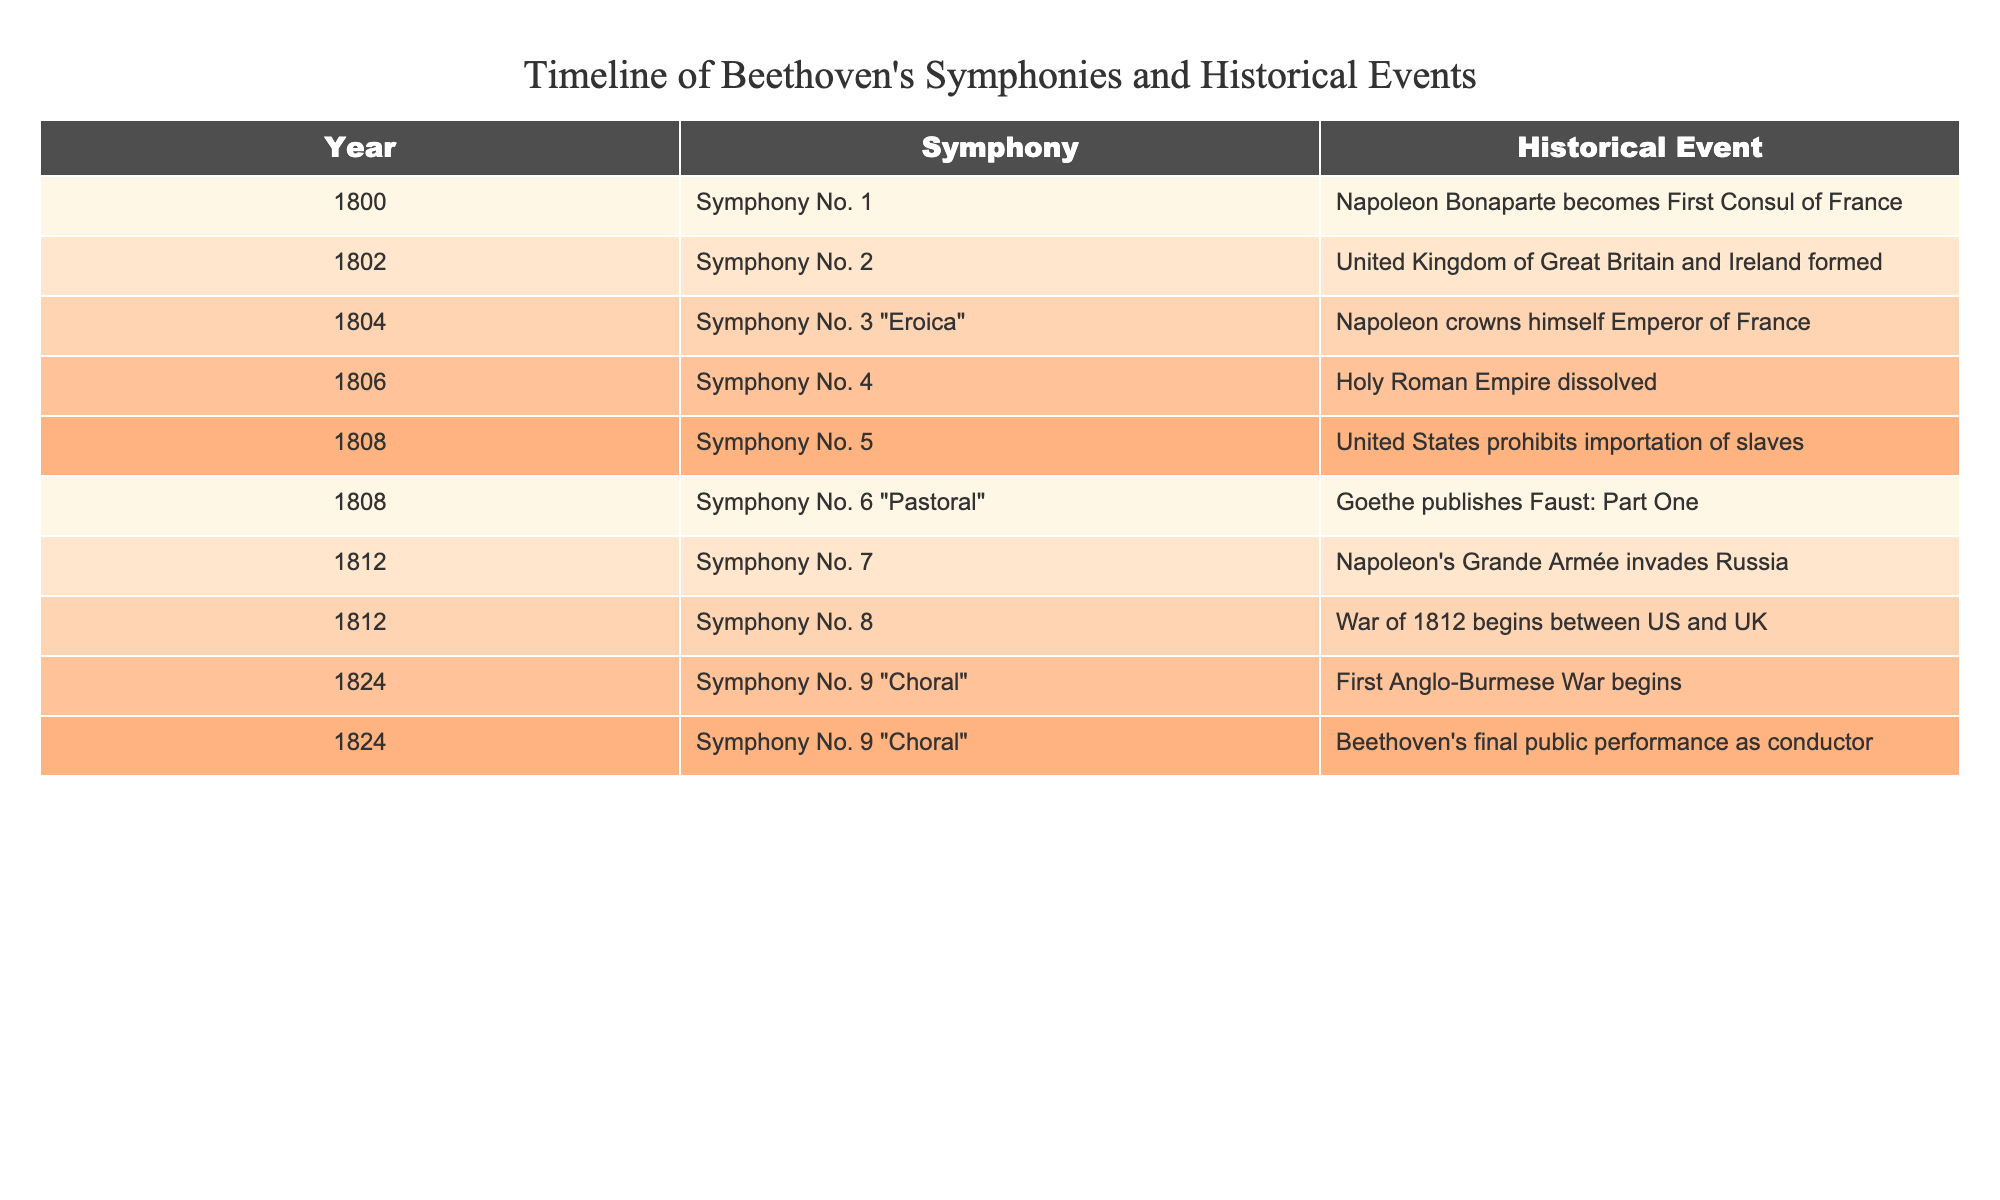What year was Beethoven's Symphony No. 5 composed? By looking at the table, Symphony No. 5 is listed under the year 1808.
Answer: 1808 What historical event is associated with Symphony No. 3 "Eroica"? The table shows that Symphony No. 3 "Eroica" is associated with Napoleon crowning himself Emperor of France in 1804.
Answer: Napoleon crowns himself Emperor of France Which symphony was composed the same year the Holy Roman Empire was dissolved? The table indicates that Symphony No. 4 was composed in 1806, which is the same year the Holy Roman Empire was dissolved.
Answer: Symphony No. 4 How many symphonies did Beethoven compose before 1810? Reviewing the table, Beethoven composed Symphony No. 1, No. 2, No. 3, No. 4, No. 5, and No. 6 before 1810, totaling 6 symphonies.
Answer: 6 Was Symphony No. 9 "Choral" performed before or after the start of the First Anglo-Burmese War? According to the table, Symphony No. 9 "Choral" was composed in 1824, and the First Anglo-Burmese War began in the same year, indicating the symphony was performed at the same time.
Answer: Same year What is the difference in years between the compositions of Symphony No. 7 and Symphony No. 2? Looking at the table, Symphony No. 7 was composed in 1812 and Symphony No. 2 was composed in 1802. Thus, the difference is 1812 - 1802 = 10 years.
Answer: 10 years Which symphony corresponds to the historical event of the War of 1812? The table indicates that Symphony No. 8 is associated with the War of 1812, which began between the US and UK in 1812.
Answer: Symphony No. 8 Is it true that Beethoven's final public performance as conductor was linked with the same symphony? Yes, the table shows that Beethoven's final public performance as conductor occurred in 1824, along with the composition of Symphony No. 9 "Choral".
Answer: Yes How many symphonies featured in the table were composed in 1808? The table lists two symphonies composed in 1808: Symphony No. 5 and Symphony No. 6 "Pastoral". Therefore, there are 2 symphonies.
Answer: 2 What significant American historical event coincides with the composition of Symphony No. 5? The table indicates that the United States prohibited the importation of slaves in 1808 when Symphony No. 5 was composed.
Answer: U.S. prohibits importation of slaves 